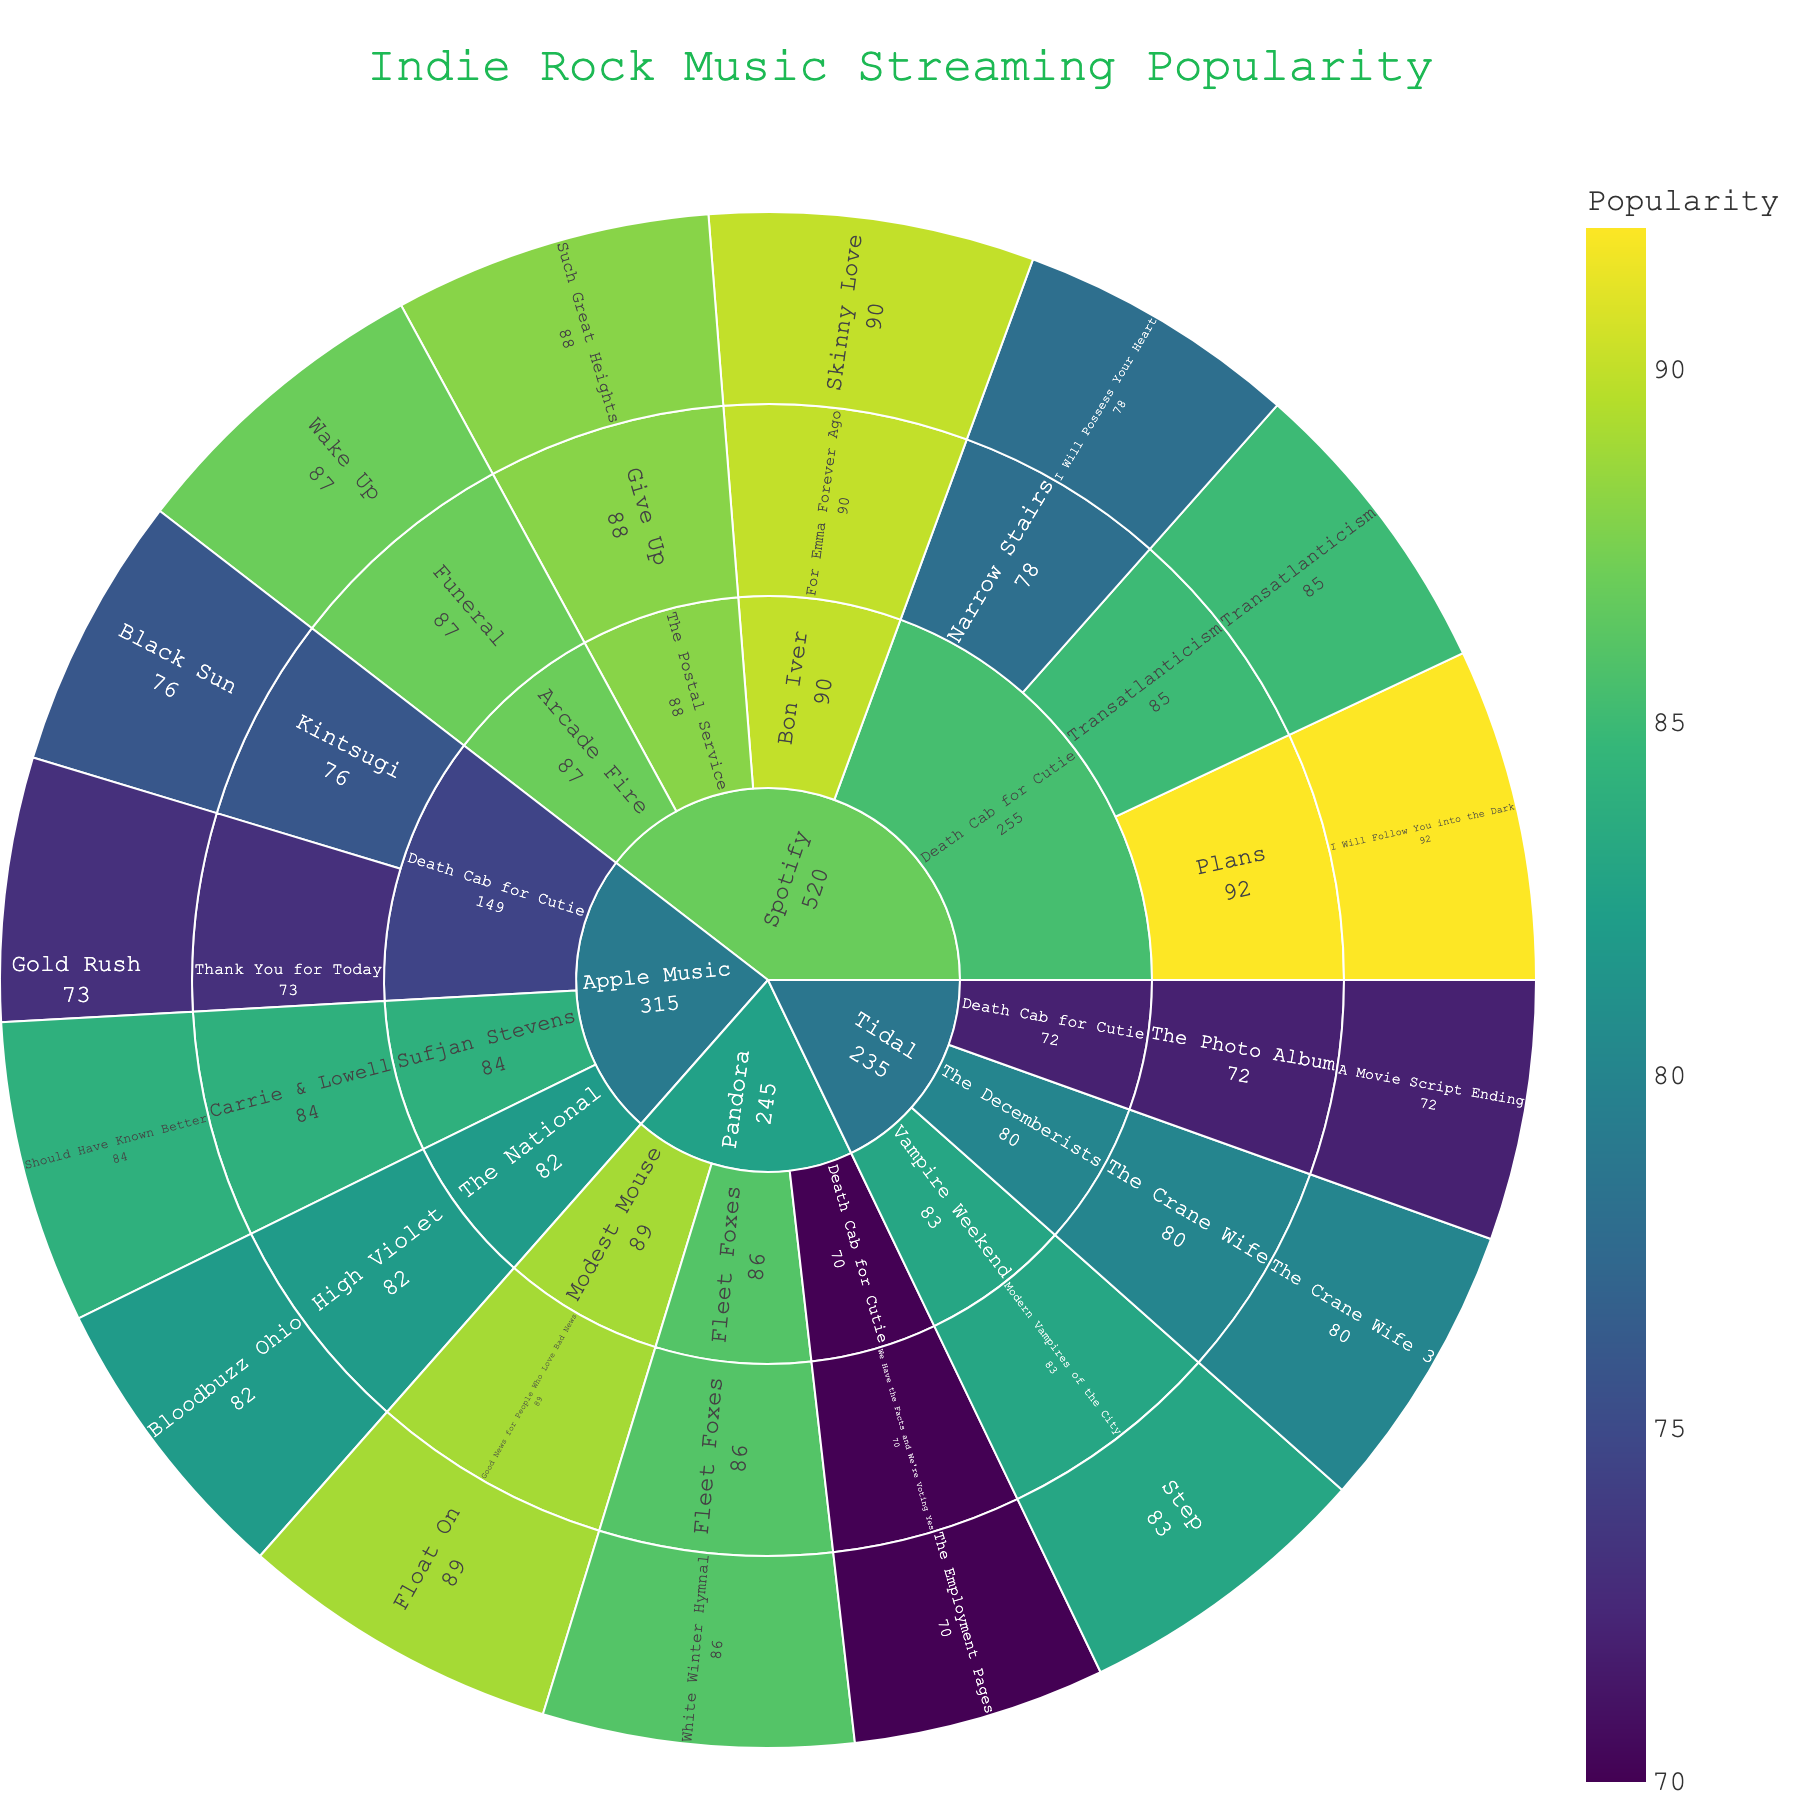What is the title of the figure? The title is usually displayed at the top of the figure and provides an overview of what the data visualization is about.
Answer: Indie Rock Music Streaming Popularity Which artist has the highest song popularity on Spotify? To determine this, look at the highest popularity value under the song subcategory for Spotify.
Answer: Death Cab for Cutie How many different platforms are represented in the Sunburst plot? By identifying the unique segments in the outermost layer of the sunburst plot, we can count the number of platforms represented.
Answer: 4 What is the most popular song by The Postal Service? Locate the segment corresponding to "The Postal Service" and find the highest popularity value for their songs.
Answer: Such Great Heights What is the average popularity of Death Cab for Cutie's songs on Apple Music? Identify the segments for Death Cab for Cutie's songs on Apple Music, sum their popularity values, and divide by the number of songs. Specifically, (76 + 73)/2 = 149/2.
Answer: 74.5 Which album by Bon Iver is represented in the sunburst? Find the segment associated with Bon Iver and identify the album name within that segment.
Answer: For Emma Forever Ago Is the song "Wake Up" by Arcade Fire more popular than "Bloodbuzz Ohio" by The National on Apple Music? Compare the popularity values of "Wake Up" by Arcade Fire on Spotify and "Bloodbuzz Ohio" by The National on Apple Music.
Answer: No What song has the lowest popularity in the figure and on which platform is it available? Identify the segment with the smallest popularity value and note its associated platform.
Answer: The Employment Pages on Pandora How many albums are represented by Death Cab for Cutie across all platforms? Count the unique album segments under the artist "Death Cab for Cutie" across all platforms.
Answer: 7 What is the sum of the popularity of all Death Cab for Cutie's songs on Tidal? Add the popularity values of Death Cab for Cutie's songs available on Tidal: 72 (A Movie Script Ending).
Answer: 72 